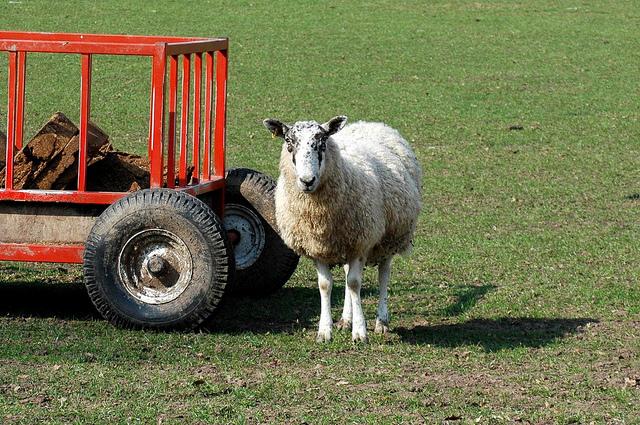What color is the cart?
Write a very short answer. Red. What is to the right of the cart?
Short answer required. Sheep. What is in the cart?
Quick response, please. Wood. 